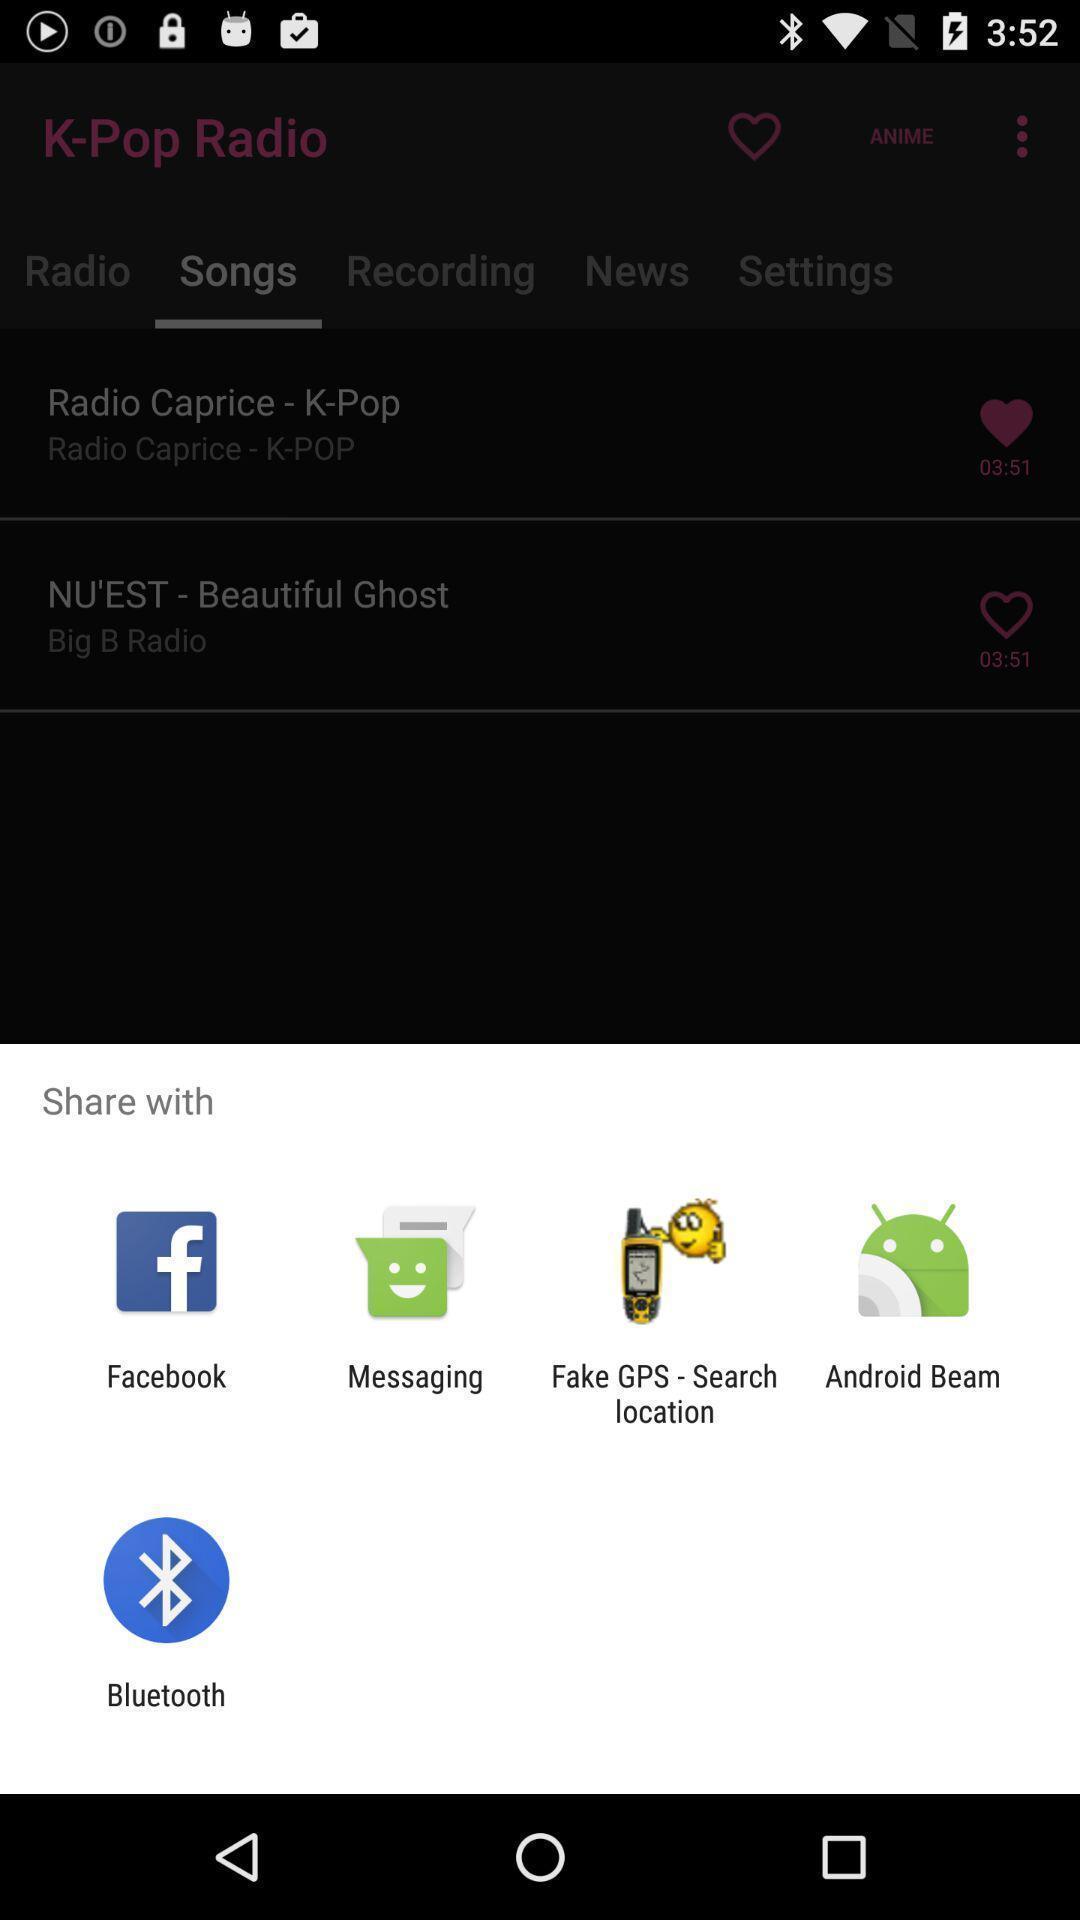Explain the elements present in this screenshot. Screen displaying to share using different social applications. 